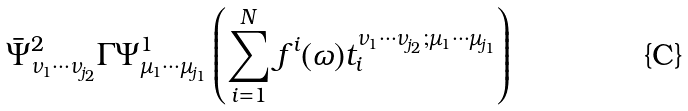Convert formula to latex. <formula><loc_0><loc_0><loc_500><loc_500>\bar { \Psi } ^ { 2 } _ { \nu _ { 1 } \cdots \nu _ { j _ { 2 } } } \Gamma \Psi _ { \mu _ { 1 } \cdots \mu _ { j _ { 1 } } } ^ { 1 } \left ( \sum _ { i = 1 } ^ { N } f ^ { i } ( \omega ) t _ { i } ^ { \nu _ { 1 } \cdots \nu _ { j _ { 2 } } ; \mu _ { 1 } \cdots \mu _ { j _ { 1 } } } \right )</formula> 